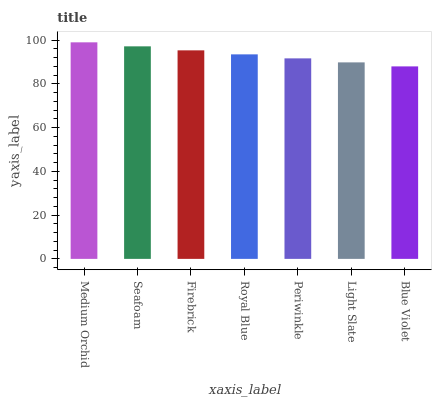Is Blue Violet the minimum?
Answer yes or no. Yes. Is Medium Orchid the maximum?
Answer yes or no. Yes. Is Seafoam the minimum?
Answer yes or no. No. Is Seafoam the maximum?
Answer yes or no. No. Is Medium Orchid greater than Seafoam?
Answer yes or no. Yes. Is Seafoam less than Medium Orchid?
Answer yes or no. Yes. Is Seafoam greater than Medium Orchid?
Answer yes or no. No. Is Medium Orchid less than Seafoam?
Answer yes or no. No. Is Royal Blue the high median?
Answer yes or no. Yes. Is Royal Blue the low median?
Answer yes or no. Yes. Is Periwinkle the high median?
Answer yes or no. No. Is Blue Violet the low median?
Answer yes or no. No. 